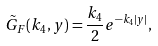Convert formula to latex. <formula><loc_0><loc_0><loc_500><loc_500>\tilde { G } _ { F } ( k _ { 4 } , y ) = \frac { k _ { 4 } } { 2 } e ^ { - k _ { 4 } | y | } ,</formula> 